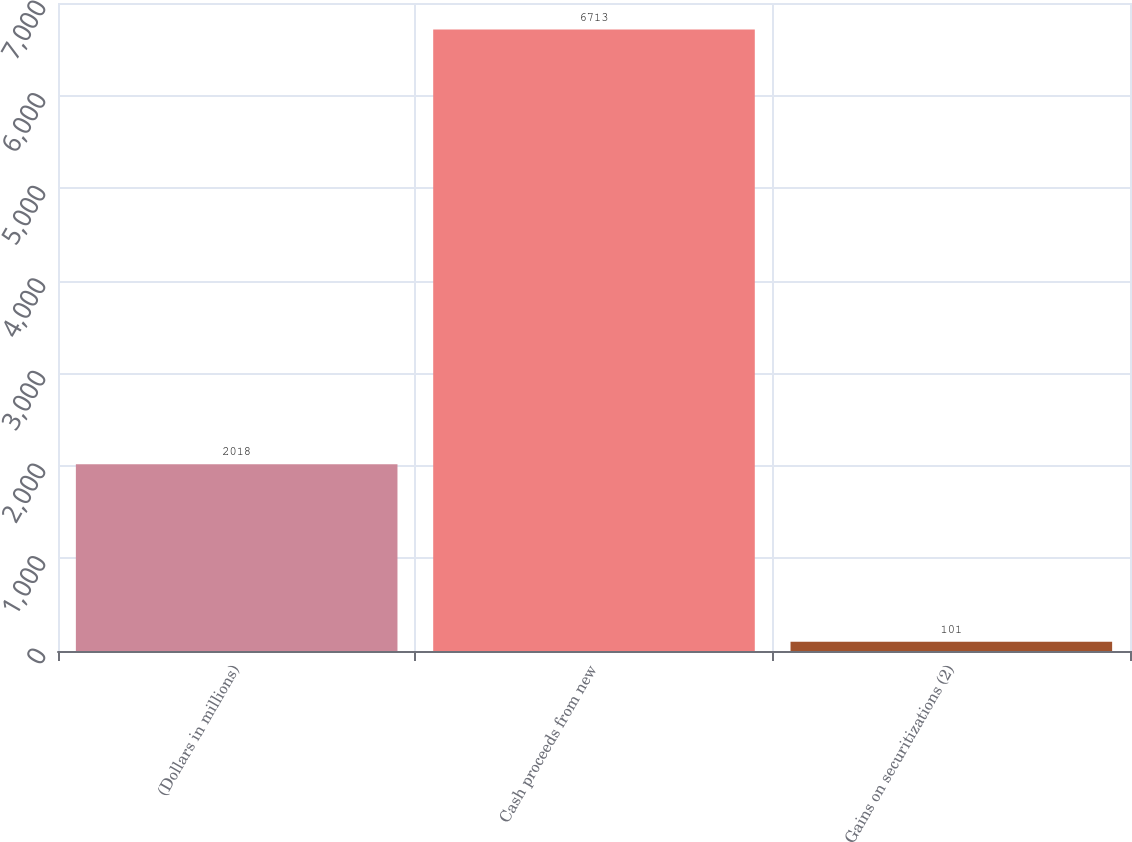<chart> <loc_0><loc_0><loc_500><loc_500><bar_chart><fcel>(Dollars in millions)<fcel>Cash proceeds from new<fcel>Gains on securitizations (2)<nl><fcel>2018<fcel>6713<fcel>101<nl></chart> 